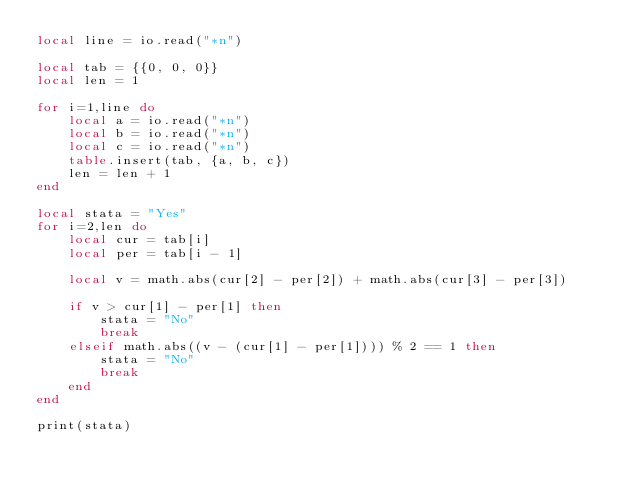<code> <loc_0><loc_0><loc_500><loc_500><_Lua_>local line = io.read("*n")

local tab = {{0, 0, 0}}
local len = 1

for i=1,line do
	local a = io.read("*n")
	local b = io.read("*n")
	local c = io.read("*n")
	table.insert(tab, {a, b, c})
	len = len + 1
end

local stata = "Yes"
for i=2,len do
	local cur = tab[i]
	local per = tab[i - 1]

	local v = math.abs(cur[2] - per[2]) + math.abs(cur[3] - per[3])

	if v > cur[1] - per[1] then
		stata = "No"
		break
	elseif math.abs((v - (cur[1] - per[1]))) % 2 == 1 then
		stata = "No"
		break
	end
end

print(stata)</code> 